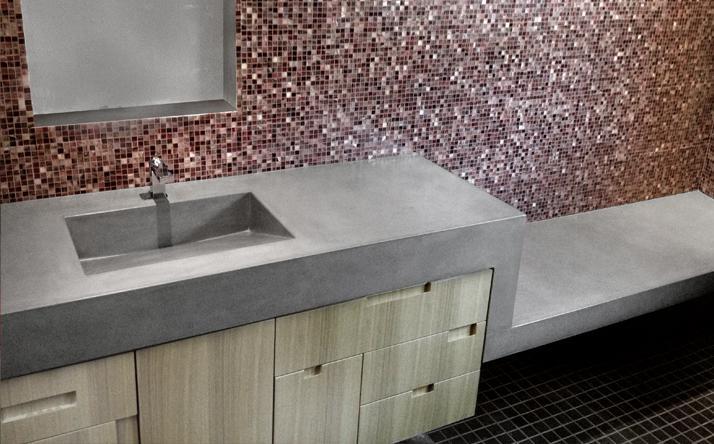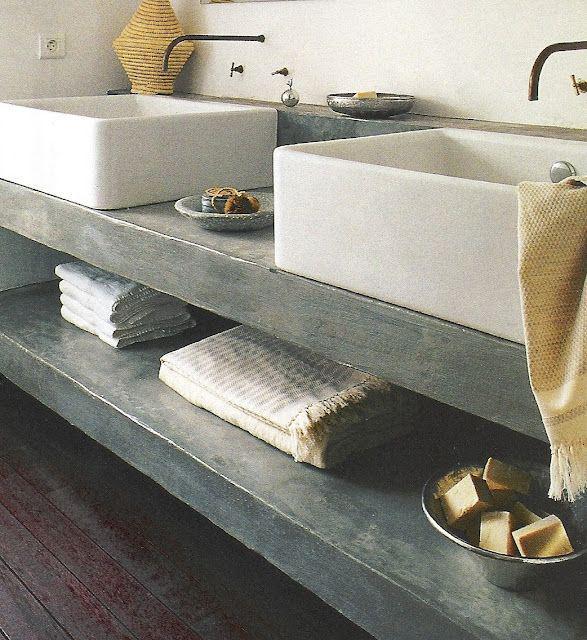The first image is the image on the left, the second image is the image on the right. Evaluate the accuracy of this statement regarding the images: "There are three faucets.". Is it true? Answer yes or no. Yes. The first image is the image on the left, the second image is the image on the right. Examine the images to the left and right. Is the description "Each image shows a grey/silver vanity with only one sink." accurate? Answer yes or no. No. 